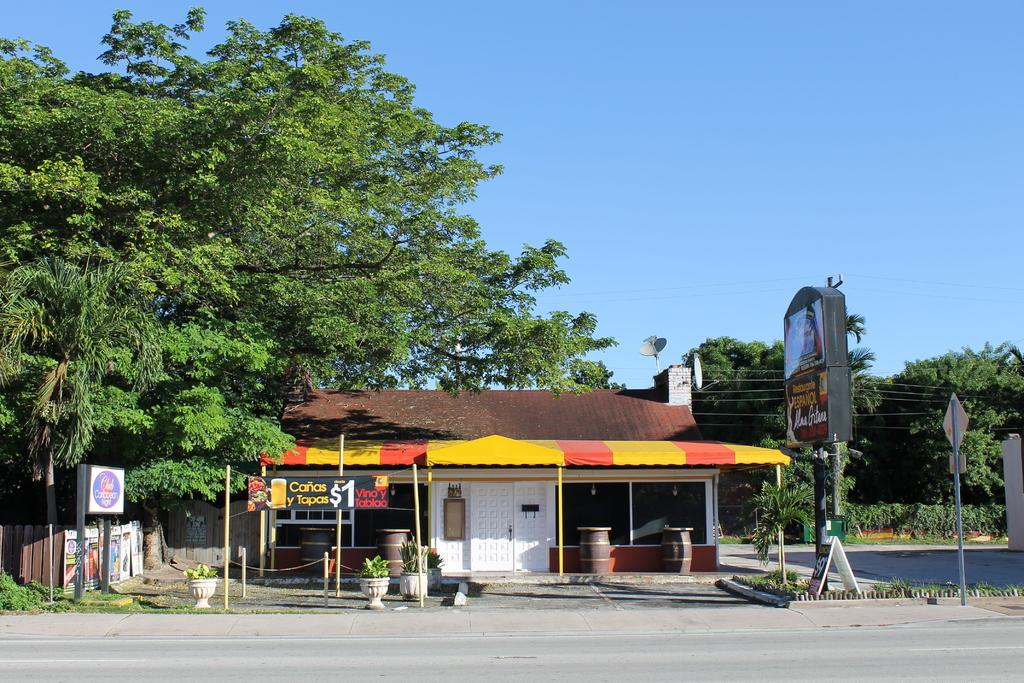What type of structure is visible in the image? There is a house with a roof in the image. What can be seen on the boards in the image? There are boards with text in the image. What are the poles and wires used for in the image? The poles and wires are likely used for supporting and transmitting electrical or communication lines. What type of barrier is present in the image? There is a fence in the image. What type of plants are in the pots in the image? There are plants in pots in the image. What type of containers are visible in the image? There are barrels in the image. What type of vegetation can be seen in the image? There is a group of trees in the image. What part of the natural environment is visible in the image? The sky is visible in the image. What type of pleasure can be seen on the face of the house in the image? There is no face present on the house in the image, so it is not possible to determine if there is any pleasure or emotion associated with it. 